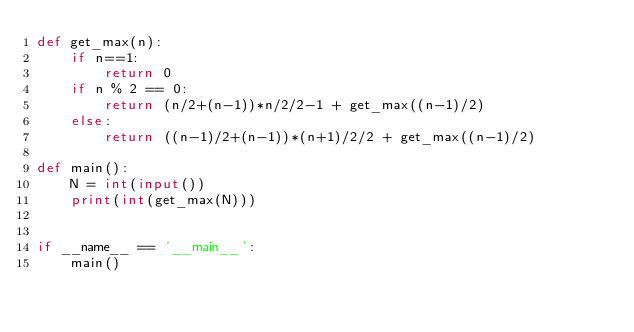Convert code to text. <code><loc_0><loc_0><loc_500><loc_500><_Python_>def get_max(n):
    if n==1:
        return 0
    if n % 2 == 0:
        return (n/2+(n-1))*n/2/2-1 + get_max((n-1)/2)
    else:
        return ((n-1)/2+(n-1))*(n+1)/2/2 + get_max((n-1)/2)

def main():
    N = int(input())
    print(int(get_max(N)))


if __name__ == '__main__':
    main()
</code> 